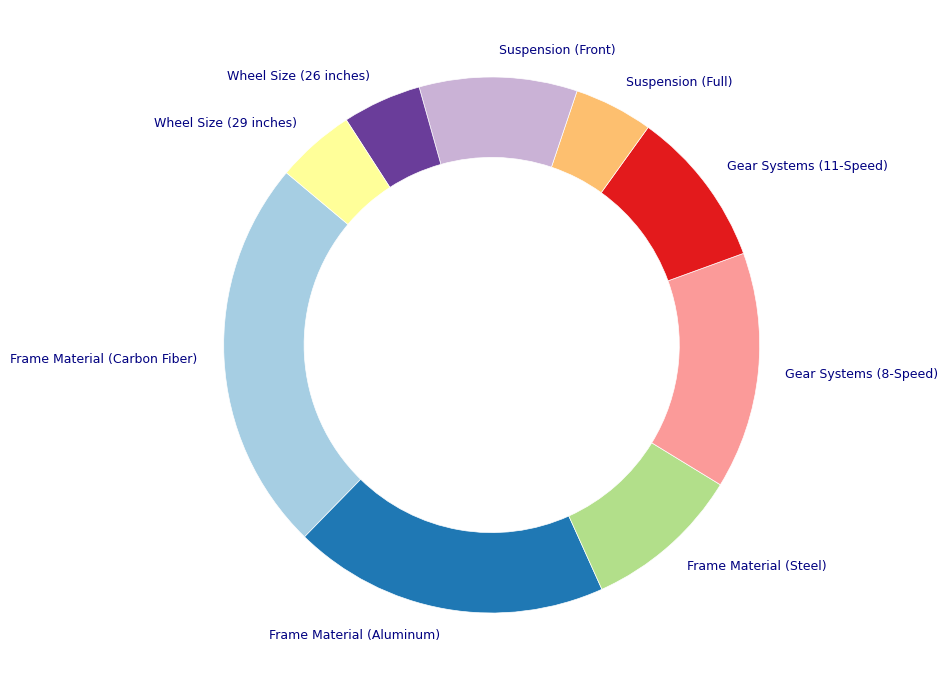What feature has the highest preference among customers? The feature with the largest section in the pie chart represents the highest preference. In this case, it's "Frame Material (Carbon Fiber)" which has 25%.
Answer: Frame Material (Carbon Fiber) Which two features have the equal lowest preference among customers? By visually inspecting the pie chart, the smallest sections represent the lowest preferences. Both "Suspension (Full)" and "Wheel Size (26 inches)" each occupy 5% of the chart.
Answer: Suspension (Full), Wheel Size (26 inches) What is the total percentage preference for all types of frame materials? By adding the percentages for all frame materials: Carbon Fiber (25%), Aluminum (20%), and Steel (10%). Summing them gives 25% + 20% + 10% = 55%.
Answer: 55% Is the preference for "Gear Systems (8-Speed)" greater than the sum of both suspension preferences? The preference for Gear Systems (8-Speed) is 15%. The sum of preferences for "Suspension (Full)" and "Suspension (Front)" is 5% + 10% = 15%. Thus, 15% is not greater than 15%.
Answer: No How do the preferences for different wheel sizes compare to each other? Both "Wheel Size (26 inches)" and "Wheel Size (29 inches)" have equal preferences, each occupying 5% of the chart.
Answer: Equal What is the difference in percentage preference between "Frame Material (Carbon Fiber)" and "Frame Material (Aluminum)"? The preference for Carbon Fiber is 25% and for Aluminum is 20%. Calculating the difference: 25% - 20% = 5%.
Answer: 5% Are the combined preferences for all features related to gear systems and suspensions greater than those for frame materials? Combined preferences for gear systems and suspensions are: 15% + 10% + 5% + 10% = 40%. Preferences for frame materials sum to 55%. Since 40% < 55%, the combined preferences for gear systems and suspensions are not greater.
Answer: No What is the average preference for all features related to gear systems? The preferences for gear systems are: 8-Speed (15%) and 11-Speed (10%). The average is calculated as (15% + 10%) / 2 = 12.5%.
Answer: 12.5% 